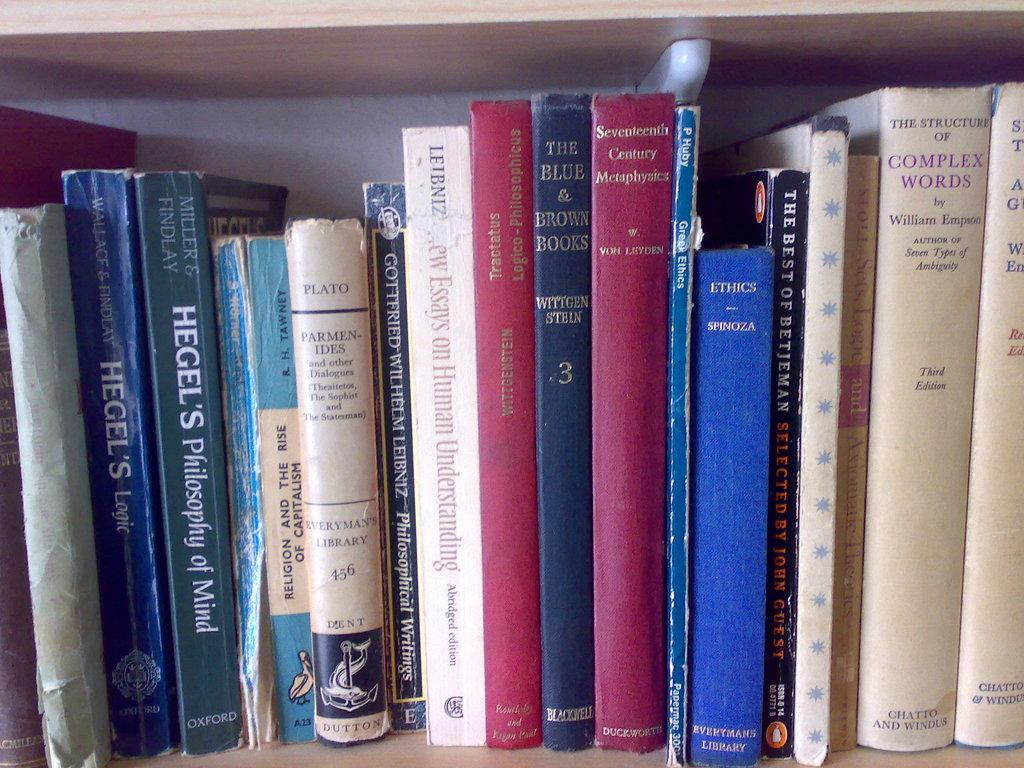Provide a one-sentence caption for the provided image. The book Hegel's Philosophy of Mind sits on a shelf with many other old books. 